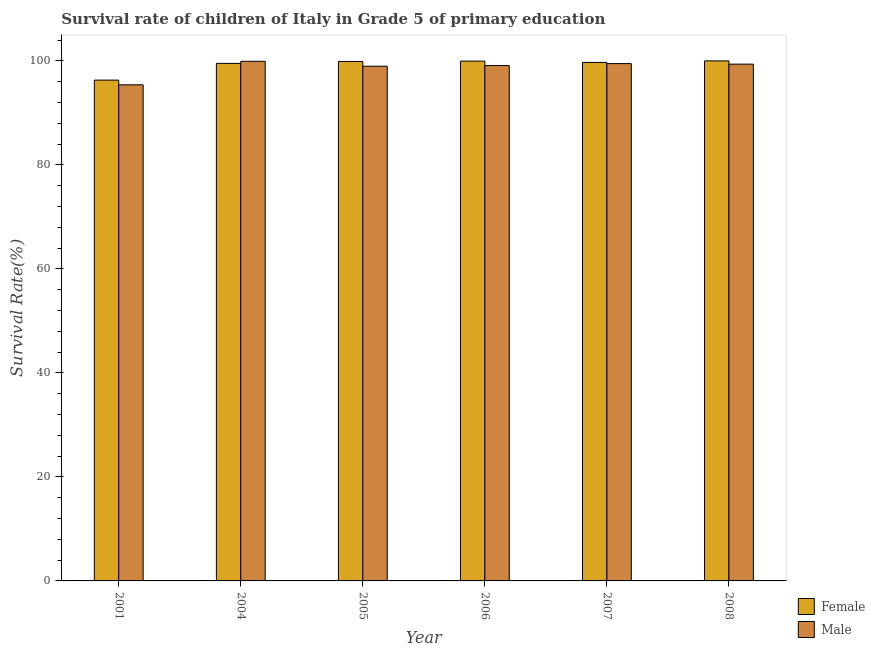How many different coloured bars are there?
Your answer should be compact. 2. How many groups of bars are there?
Your response must be concise. 6. What is the survival rate of male students in primary education in 2001?
Make the answer very short. 95.38. Across all years, what is the maximum survival rate of male students in primary education?
Provide a succinct answer. 99.91. Across all years, what is the minimum survival rate of female students in primary education?
Your response must be concise. 96.29. In which year was the survival rate of male students in primary education maximum?
Ensure brevity in your answer.  2004. In which year was the survival rate of female students in primary education minimum?
Make the answer very short. 2001. What is the total survival rate of female students in primary education in the graph?
Keep it short and to the point. 595.29. What is the difference between the survival rate of male students in primary education in 2005 and that in 2007?
Your answer should be compact. -0.5. What is the difference between the survival rate of female students in primary education in 2001 and the survival rate of male students in primary education in 2007?
Give a very brief answer. -3.4. What is the average survival rate of male students in primary education per year?
Offer a very short reply. 98.69. What is the ratio of the survival rate of female students in primary education in 2007 to that in 2008?
Your answer should be compact. 1. What is the difference between the highest and the second highest survival rate of female students in primary education?
Your answer should be compact. 0.04. What is the difference between the highest and the lowest survival rate of male students in primary education?
Keep it short and to the point. 4.52. In how many years, is the survival rate of male students in primary education greater than the average survival rate of male students in primary education taken over all years?
Make the answer very short. 5. What does the 1st bar from the right in 2001 represents?
Provide a short and direct response. Male. Are all the bars in the graph horizontal?
Your response must be concise. No. How many years are there in the graph?
Give a very brief answer. 6. What is the difference between two consecutive major ticks on the Y-axis?
Make the answer very short. 20. Are the values on the major ticks of Y-axis written in scientific E-notation?
Keep it short and to the point. No. Does the graph contain any zero values?
Make the answer very short. No. Where does the legend appear in the graph?
Your response must be concise. Bottom right. How many legend labels are there?
Provide a succinct answer. 2. What is the title of the graph?
Make the answer very short. Survival rate of children of Italy in Grade 5 of primary education. Does "Male population" appear as one of the legend labels in the graph?
Your answer should be compact. No. What is the label or title of the Y-axis?
Provide a short and direct response. Survival Rate(%). What is the Survival Rate(%) of Female in 2001?
Make the answer very short. 96.29. What is the Survival Rate(%) in Male in 2001?
Make the answer very short. 95.38. What is the Survival Rate(%) of Female in 2004?
Ensure brevity in your answer.  99.5. What is the Survival Rate(%) of Male in 2004?
Make the answer very short. 99.91. What is the Survival Rate(%) of Female in 2005?
Your response must be concise. 99.88. What is the Survival Rate(%) of Male in 2005?
Your response must be concise. 98.96. What is the Survival Rate(%) of Female in 2006?
Give a very brief answer. 99.95. What is the Survival Rate(%) in Male in 2006?
Ensure brevity in your answer.  99.08. What is the Survival Rate(%) in Female in 2007?
Ensure brevity in your answer.  99.69. What is the Survival Rate(%) of Male in 2007?
Make the answer very short. 99.47. What is the Survival Rate(%) of Female in 2008?
Your answer should be very brief. 99.99. What is the Survival Rate(%) of Male in 2008?
Your answer should be very brief. 99.36. Across all years, what is the maximum Survival Rate(%) of Female?
Provide a short and direct response. 99.99. Across all years, what is the maximum Survival Rate(%) of Male?
Provide a succinct answer. 99.91. Across all years, what is the minimum Survival Rate(%) of Female?
Offer a very short reply. 96.29. Across all years, what is the minimum Survival Rate(%) in Male?
Keep it short and to the point. 95.38. What is the total Survival Rate(%) in Female in the graph?
Make the answer very short. 595.29. What is the total Survival Rate(%) of Male in the graph?
Provide a succinct answer. 592.16. What is the difference between the Survival Rate(%) of Female in 2001 and that in 2004?
Make the answer very short. -3.22. What is the difference between the Survival Rate(%) in Male in 2001 and that in 2004?
Your response must be concise. -4.52. What is the difference between the Survival Rate(%) in Female in 2001 and that in 2005?
Give a very brief answer. -3.59. What is the difference between the Survival Rate(%) in Male in 2001 and that in 2005?
Offer a terse response. -3.58. What is the difference between the Survival Rate(%) of Female in 2001 and that in 2006?
Make the answer very short. -3.66. What is the difference between the Survival Rate(%) in Male in 2001 and that in 2006?
Offer a terse response. -3.7. What is the difference between the Survival Rate(%) of Female in 2001 and that in 2007?
Provide a short and direct response. -3.4. What is the difference between the Survival Rate(%) of Male in 2001 and that in 2007?
Keep it short and to the point. -4.09. What is the difference between the Survival Rate(%) of Female in 2001 and that in 2008?
Provide a short and direct response. -3.7. What is the difference between the Survival Rate(%) in Male in 2001 and that in 2008?
Provide a succinct answer. -3.97. What is the difference between the Survival Rate(%) of Female in 2004 and that in 2005?
Your answer should be very brief. -0.37. What is the difference between the Survival Rate(%) in Male in 2004 and that in 2005?
Ensure brevity in your answer.  0.94. What is the difference between the Survival Rate(%) of Female in 2004 and that in 2006?
Your answer should be compact. -0.44. What is the difference between the Survival Rate(%) of Male in 2004 and that in 2006?
Your response must be concise. 0.82. What is the difference between the Survival Rate(%) in Female in 2004 and that in 2007?
Offer a very short reply. -0.19. What is the difference between the Survival Rate(%) in Male in 2004 and that in 2007?
Keep it short and to the point. 0.44. What is the difference between the Survival Rate(%) in Female in 2004 and that in 2008?
Your response must be concise. -0.48. What is the difference between the Survival Rate(%) of Male in 2004 and that in 2008?
Your answer should be very brief. 0.55. What is the difference between the Survival Rate(%) of Female in 2005 and that in 2006?
Keep it short and to the point. -0.07. What is the difference between the Survival Rate(%) of Male in 2005 and that in 2006?
Make the answer very short. -0.12. What is the difference between the Survival Rate(%) of Female in 2005 and that in 2007?
Keep it short and to the point. 0.18. What is the difference between the Survival Rate(%) in Male in 2005 and that in 2007?
Keep it short and to the point. -0.5. What is the difference between the Survival Rate(%) in Female in 2005 and that in 2008?
Your answer should be compact. -0.11. What is the difference between the Survival Rate(%) in Male in 2005 and that in 2008?
Make the answer very short. -0.39. What is the difference between the Survival Rate(%) of Female in 2006 and that in 2007?
Give a very brief answer. 0.25. What is the difference between the Survival Rate(%) of Male in 2006 and that in 2007?
Provide a succinct answer. -0.38. What is the difference between the Survival Rate(%) in Female in 2006 and that in 2008?
Give a very brief answer. -0.04. What is the difference between the Survival Rate(%) of Male in 2006 and that in 2008?
Your answer should be very brief. -0.27. What is the difference between the Survival Rate(%) in Female in 2007 and that in 2008?
Give a very brief answer. -0.29. What is the difference between the Survival Rate(%) in Male in 2007 and that in 2008?
Offer a very short reply. 0.11. What is the difference between the Survival Rate(%) in Female in 2001 and the Survival Rate(%) in Male in 2004?
Provide a succinct answer. -3.62. What is the difference between the Survival Rate(%) of Female in 2001 and the Survival Rate(%) of Male in 2005?
Your answer should be very brief. -2.67. What is the difference between the Survival Rate(%) of Female in 2001 and the Survival Rate(%) of Male in 2006?
Your answer should be very brief. -2.79. What is the difference between the Survival Rate(%) of Female in 2001 and the Survival Rate(%) of Male in 2007?
Offer a terse response. -3.18. What is the difference between the Survival Rate(%) of Female in 2001 and the Survival Rate(%) of Male in 2008?
Your answer should be compact. -3.07. What is the difference between the Survival Rate(%) of Female in 2004 and the Survival Rate(%) of Male in 2005?
Provide a succinct answer. 0.54. What is the difference between the Survival Rate(%) in Female in 2004 and the Survival Rate(%) in Male in 2006?
Offer a terse response. 0.42. What is the difference between the Survival Rate(%) in Female in 2004 and the Survival Rate(%) in Male in 2007?
Offer a very short reply. 0.04. What is the difference between the Survival Rate(%) of Female in 2004 and the Survival Rate(%) of Male in 2008?
Give a very brief answer. 0.15. What is the difference between the Survival Rate(%) in Female in 2005 and the Survival Rate(%) in Male in 2006?
Give a very brief answer. 0.79. What is the difference between the Survival Rate(%) in Female in 2005 and the Survival Rate(%) in Male in 2007?
Give a very brief answer. 0.41. What is the difference between the Survival Rate(%) in Female in 2005 and the Survival Rate(%) in Male in 2008?
Your response must be concise. 0.52. What is the difference between the Survival Rate(%) of Female in 2006 and the Survival Rate(%) of Male in 2007?
Provide a short and direct response. 0.48. What is the difference between the Survival Rate(%) of Female in 2006 and the Survival Rate(%) of Male in 2008?
Keep it short and to the point. 0.59. What is the difference between the Survival Rate(%) in Female in 2007 and the Survival Rate(%) in Male in 2008?
Make the answer very short. 0.34. What is the average Survival Rate(%) in Female per year?
Provide a short and direct response. 99.22. What is the average Survival Rate(%) of Male per year?
Give a very brief answer. 98.69. In the year 2001, what is the difference between the Survival Rate(%) of Female and Survival Rate(%) of Male?
Ensure brevity in your answer.  0.91. In the year 2004, what is the difference between the Survival Rate(%) in Female and Survival Rate(%) in Male?
Your response must be concise. -0.4. In the year 2005, what is the difference between the Survival Rate(%) in Female and Survival Rate(%) in Male?
Your answer should be very brief. 0.91. In the year 2006, what is the difference between the Survival Rate(%) of Female and Survival Rate(%) of Male?
Provide a succinct answer. 0.86. In the year 2007, what is the difference between the Survival Rate(%) of Female and Survival Rate(%) of Male?
Provide a short and direct response. 0.23. In the year 2008, what is the difference between the Survival Rate(%) in Female and Survival Rate(%) in Male?
Keep it short and to the point. 0.63. What is the ratio of the Survival Rate(%) of Female in 2001 to that in 2004?
Give a very brief answer. 0.97. What is the ratio of the Survival Rate(%) in Male in 2001 to that in 2004?
Keep it short and to the point. 0.95. What is the ratio of the Survival Rate(%) of Female in 2001 to that in 2005?
Give a very brief answer. 0.96. What is the ratio of the Survival Rate(%) of Male in 2001 to that in 2005?
Keep it short and to the point. 0.96. What is the ratio of the Survival Rate(%) of Female in 2001 to that in 2006?
Your response must be concise. 0.96. What is the ratio of the Survival Rate(%) in Male in 2001 to that in 2006?
Provide a short and direct response. 0.96. What is the ratio of the Survival Rate(%) in Female in 2001 to that in 2007?
Offer a terse response. 0.97. What is the ratio of the Survival Rate(%) of Male in 2001 to that in 2007?
Give a very brief answer. 0.96. What is the ratio of the Survival Rate(%) of Female in 2001 to that in 2008?
Provide a short and direct response. 0.96. What is the ratio of the Survival Rate(%) of Female in 2004 to that in 2005?
Your answer should be very brief. 1. What is the ratio of the Survival Rate(%) in Male in 2004 to that in 2005?
Offer a terse response. 1.01. What is the ratio of the Survival Rate(%) of Female in 2004 to that in 2006?
Keep it short and to the point. 1. What is the ratio of the Survival Rate(%) of Male in 2004 to that in 2006?
Make the answer very short. 1.01. What is the ratio of the Survival Rate(%) of Male in 2004 to that in 2007?
Your response must be concise. 1. What is the ratio of the Survival Rate(%) of Female in 2004 to that in 2008?
Keep it short and to the point. 1. What is the ratio of the Survival Rate(%) in Male in 2005 to that in 2006?
Provide a short and direct response. 1. What is the ratio of the Survival Rate(%) in Male in 2005 to that in 2007?
Your answer should be very brief. 0.99. What is the ratio of the Survival Rate(%) of Female in 2006 to that in 2007?
Ensure brevity in your answer.  1. What is the ratio of the Survival Rate(%) of Male in 2006 to that in 2007?
Your answer should be compact. 1. What is the ratio of the Survival Rate(%) of Female in 2007 to that in 2008?
Give a very brief answer. 1. What is the difference between the highest and the second highest Survival Rate(%) in Female?
Ensure brevity in your answer.  0.04. What is the difference between the highest and the second highest Survival Rate(%) of Male?
Your response must be concise. 0.44. What is the difference between the highest and the lowest Survival Rate(%) in Female?
Make the answer very short. 3.7. What is the difference between the highest and the lowest Survival Rate(%) in Male?
Offer a very short reply. 4.52. 